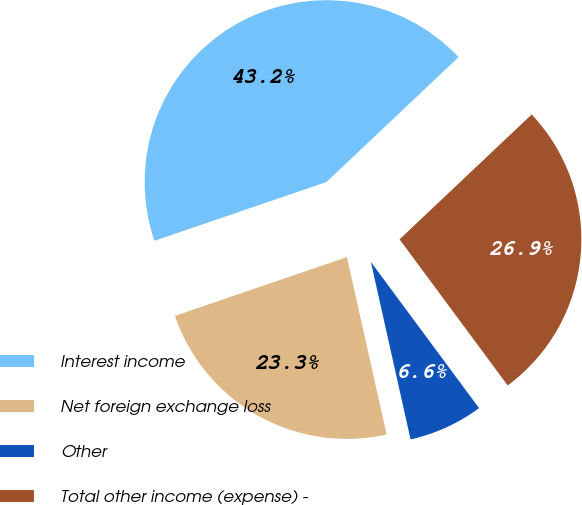Convert chart. <chart><loc_0><loc_0><loc_500><loc_500><pie_chart><fcel>Interest income<fcel>Net foreign exchange loss<fcel>Other<fcel>Total other income (expense) -<nl><fcel>43.19%<fcel>23.26%<fcel>6.64%<fcel>26.91%<nl></chart> 